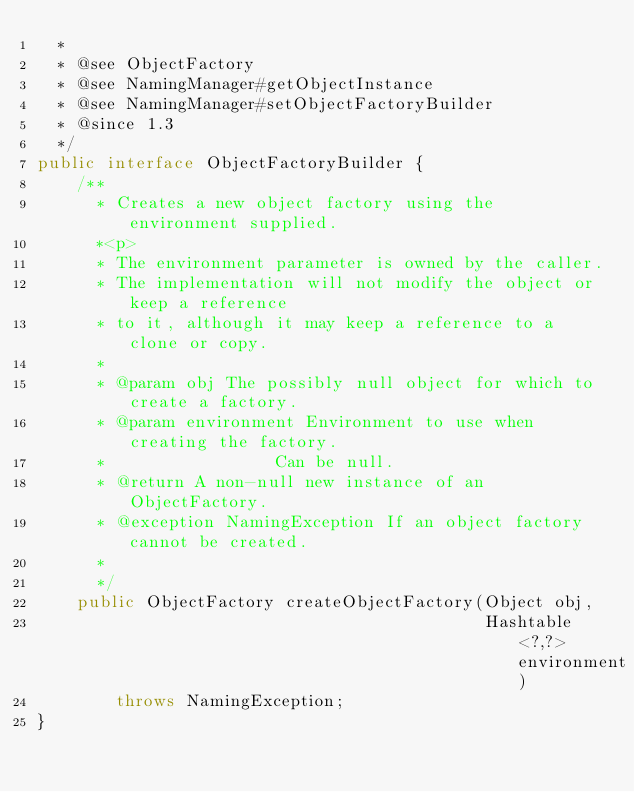Convert code to text. <code><loc_0><loc_0><loc_500><loc_500><_Java_>  *
  * @see ObjectFactory
  * @see NamingManager#getObjectInstance
  * @see NamingManager#setObjectFactoryBuilder
  * @since 1.3
  */
public interface ObjectFactoryBuilder {
    /**
      * Creates a new object factory using the environment supplied.
      *<p>
      * The environment parameter is owned by the caller.
      * The implementation will not modify the object or keep a reference
      * to it, although it may keep a reference to a clone or copy.
      *
      * @param obj The possibly null object for which to create a factory.
      * @param environment Environment to use when creating the factory.
      *                 Can be null.
      * @return A non-null new instance of an ObjectFactory.
      * @exception NamingException If an object factory cannot be created.
      *
      */
    public ObjectFactory createObjectFactory(Object obj,
                                             Hashtable<?,?> environment)
        throws NamingException;
}
</code> 